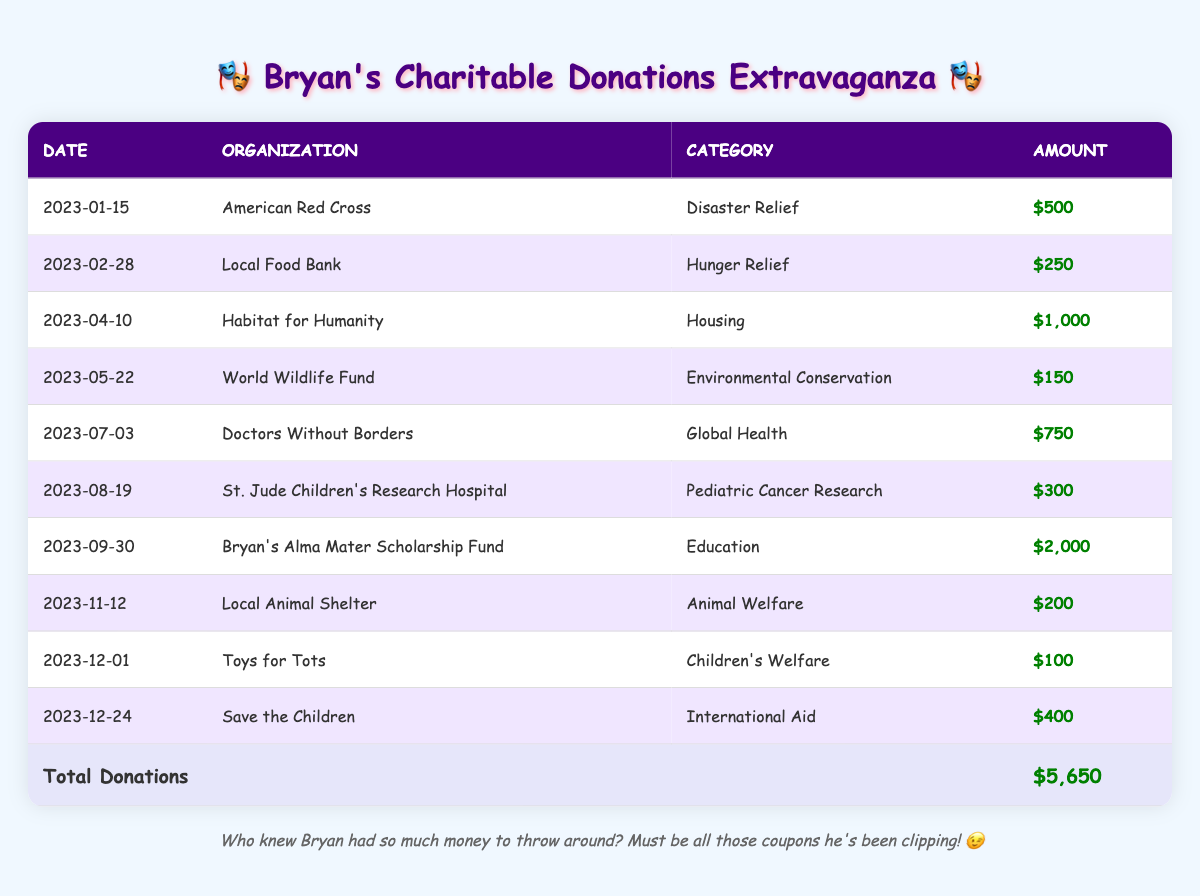What is the total amount Bryan donated to charity in 2023? To find the total donations, I need to add up all the amounts listed in the table. The donations are: 500, 250, 1000, 150, 750, 300, 2000, 200, 100, and 400. Adding these up gives: 500 + 250 + 1000 + 150 + 750 + 300 + 2000 + 200 + 100 + 400 = 5650.
Answer: 5650 What was the largest single donation made by Bryan? By scanning the "Amount" column, I see the highest value is 2000, given to "Bryan's Alma Mater Scholarship Fund."
Answer: 2000 Did Bryan donate to any animal welfare organization? Looking through the organization names in the table, I see "Local Animal Shelter" listed under the "Animal Welfare" category, indicating a donation was indeed made in this type.
Answer: Yes Which month did Bryan make his donation to the Doctors Without Borders organization? The date for that donation is identified in the table as July 3, 2023. Therefore, he made this donation in July.
Answer: July How much did Bryan donate to hunger relief causes? In the table, the amount for "Local Food Bank," which falls under this category, is 250. There are no other donations listed for hunger relief, so the total is simply this amount: 250.
Answer: 250 Which category received the lowest donation from Bryan? I will review the "Category" column and compare the respective amounts: Disaster Relief (500), Hunger Relief (250), Housing (1000), Environmental Conservation (150), Global Health (750), Pediatric Cancer Research (300), Education (2000), Animal Welfare (200), Children's Welfare (100), and International Aid (400). The lowest amount is for "Toys for Tots" under Children's Welfare at 100.
Answer: 100 How many organizations did Bryan support in total? Counting the number of entries in the table, there are 10 unique organizations listed. This indicates that Bryan supported a total of 10 organizations throughout the year.
Answer: 10 Is it true that Bryan made a donation for pediatric cancer research? The table shows an entry for "St. Jude Children's Research Hospital," which is categorized under Pediatric Cancer Research, confirming that he did make a donation for this cause.
Answer: Yes What were the two categories that received the most funding from Bryan? Analyzing each category's total contributions, I see that "Education" (2000) and "Housing" (1000) received the most funding. These are the top two categories with the highest donation amounts.
Answer: Education and Housing 